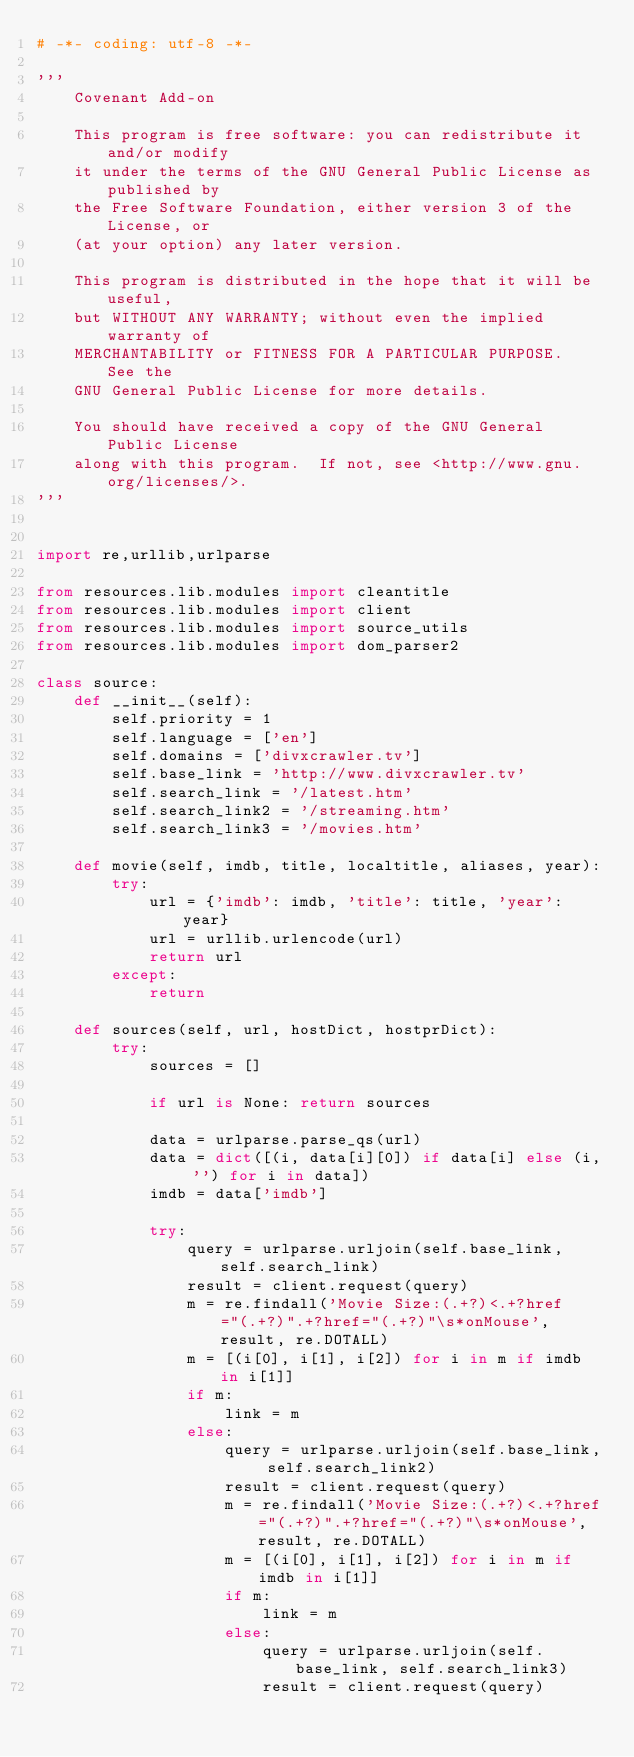Convert code to text. <code><loc_0><loc_0><loc_500><loc_500><_Python_># -*- coding: utf-8 -*-

'''
    Covenant Add-on

    This program is free software: you can redistribute it and/or modify
    it under the terms of the GNU General Public License as published by
    the Free Software Foundation, either version 3 of the License, or
    (at your option) any later version.

    This program is distributed in the hope that it will be useful,
    but WITHOUT ANY WARRANTY; without even the implied warranty of
    MERCHANTABILITY or FITNESS FOR A PARTICULAR PURPOSE.  See the
    GNU General Public License for more details.

    You should have received a copy of the GNU General Public License
    along with this program.  If not, see <http://www.gnu.org/licenses/>.
'''


import re,urllib,urlparse

from resources.lib.modules import cleantitle
from resources.lib.modules import client
from resources.lib.modules import source_utils
from resources.lib.modules import dom_parser2

class source:
    def __init__(self):
        self.priority = 1
        self.language = ['en']
        self.domains = ['divxcrawler.tv']
        self.base_link = 'http://www.divxcrawler.tv'
        self.search_link = '/latest.htm'
        self.search_link2 = '/streaming.htm'
        self.search_link3 = '/movies.htm'

    def movie(self, imdb, title, localtitle, aliases, year):
        try:
            url = {'imdb': imdb, 'title': title, 'year': year}
            url = urllib.urlencode(url)
            return url
        except:
            return

    def sources(self, url, hostDict, hostprDict):
        try:
            sources = []

            if url is None: return sources

            data = urlparse.parse_qs(url)
            data = dict([(i, data[i][0]) if data[i] else (i, '') for i in data])
            imdb = data['imdb']

            try:
                query = urlparse.urljoin(self.base_link, self.search_link)
                result = client.request(query)
                m = re.findall('Movie Size:(.+?)<.+?href="(.+?)".+?href="(.+?)"\s*onMouse', result, re.DOTALL)
                m = [(i[0], i[1], i[2]) for i in m if imdb in i[1]]
                if m:
                    link = m
                else:
                    query = urlparse.urljoin(self.base_link, self.search_link2)
                    result = client.request(query)
                    m = re.findall('Movie Size:(.+?)<.+?href="(.+?)".+?href="(.+?)"\s*onMouse', result, re.DOTALL)
                    m = [(i[0], i[1], i[2]) for i in m if imdb in i[1]]
                    if m:
                        link = m
                    else:
                        query = urlparse.urljoin(self.base_link, self.search_link3)
                        result = client.request(query)</code> 